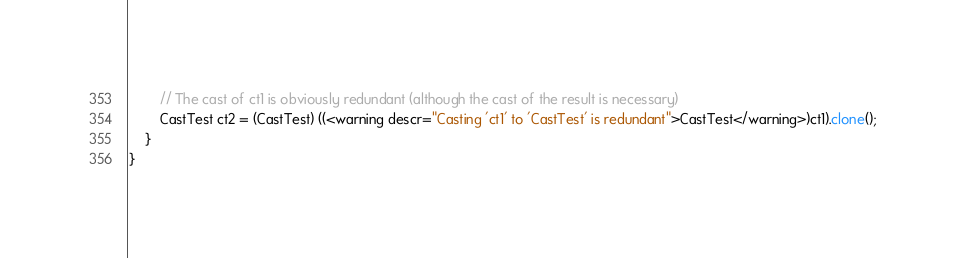Convert code to text. <code><loc_0><loc_0><loc_500><loc_500><_Java_>        // The cast of ct1 is obviously redundant (although the cast of the result is necessary)
        CastTest ct2 = (CastTest) ((<warning descr="Casting 'ct1' to 'CastTest' is redundant">CastTest</warning>)ct1).clone();
    }
}</code> 